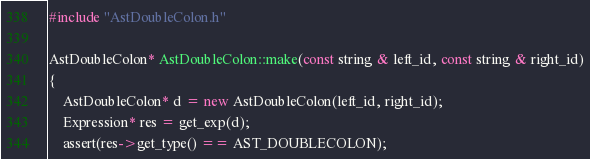Convert code to text. <code><loc_0><loc_0><loc_500><loc_500><_C++_>#include "AstDoubleColon.h"

AstDoubleColon* AstDoubleColon::make(const string & left_id, const string & right_id)
{
	AstDoubleColon* d = new AstDoubleColon(left_id, right_id);
	Expression* res = get_exp(d);
	assert(res->get_type() == AST_DOUBLECOLON);</code> 